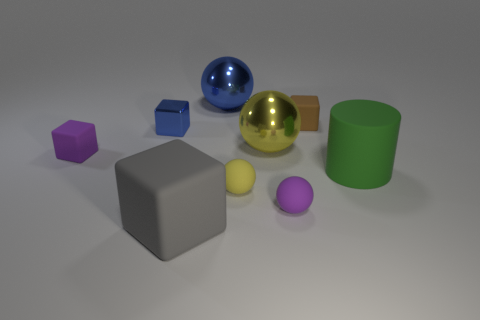Is there any pattern or order in how the objects are arranged? There doesn't appear to be a specific pattern to the arrangement of the objects; they are placed randomly across the surface. Can you tell me which objects are reflective and which are not? Certainly, the gold-colored sphere and the smaller metallic cube exhibit reflective surfaces, while the rest of the objects have matte finishes that do not reflect light in the same way. 